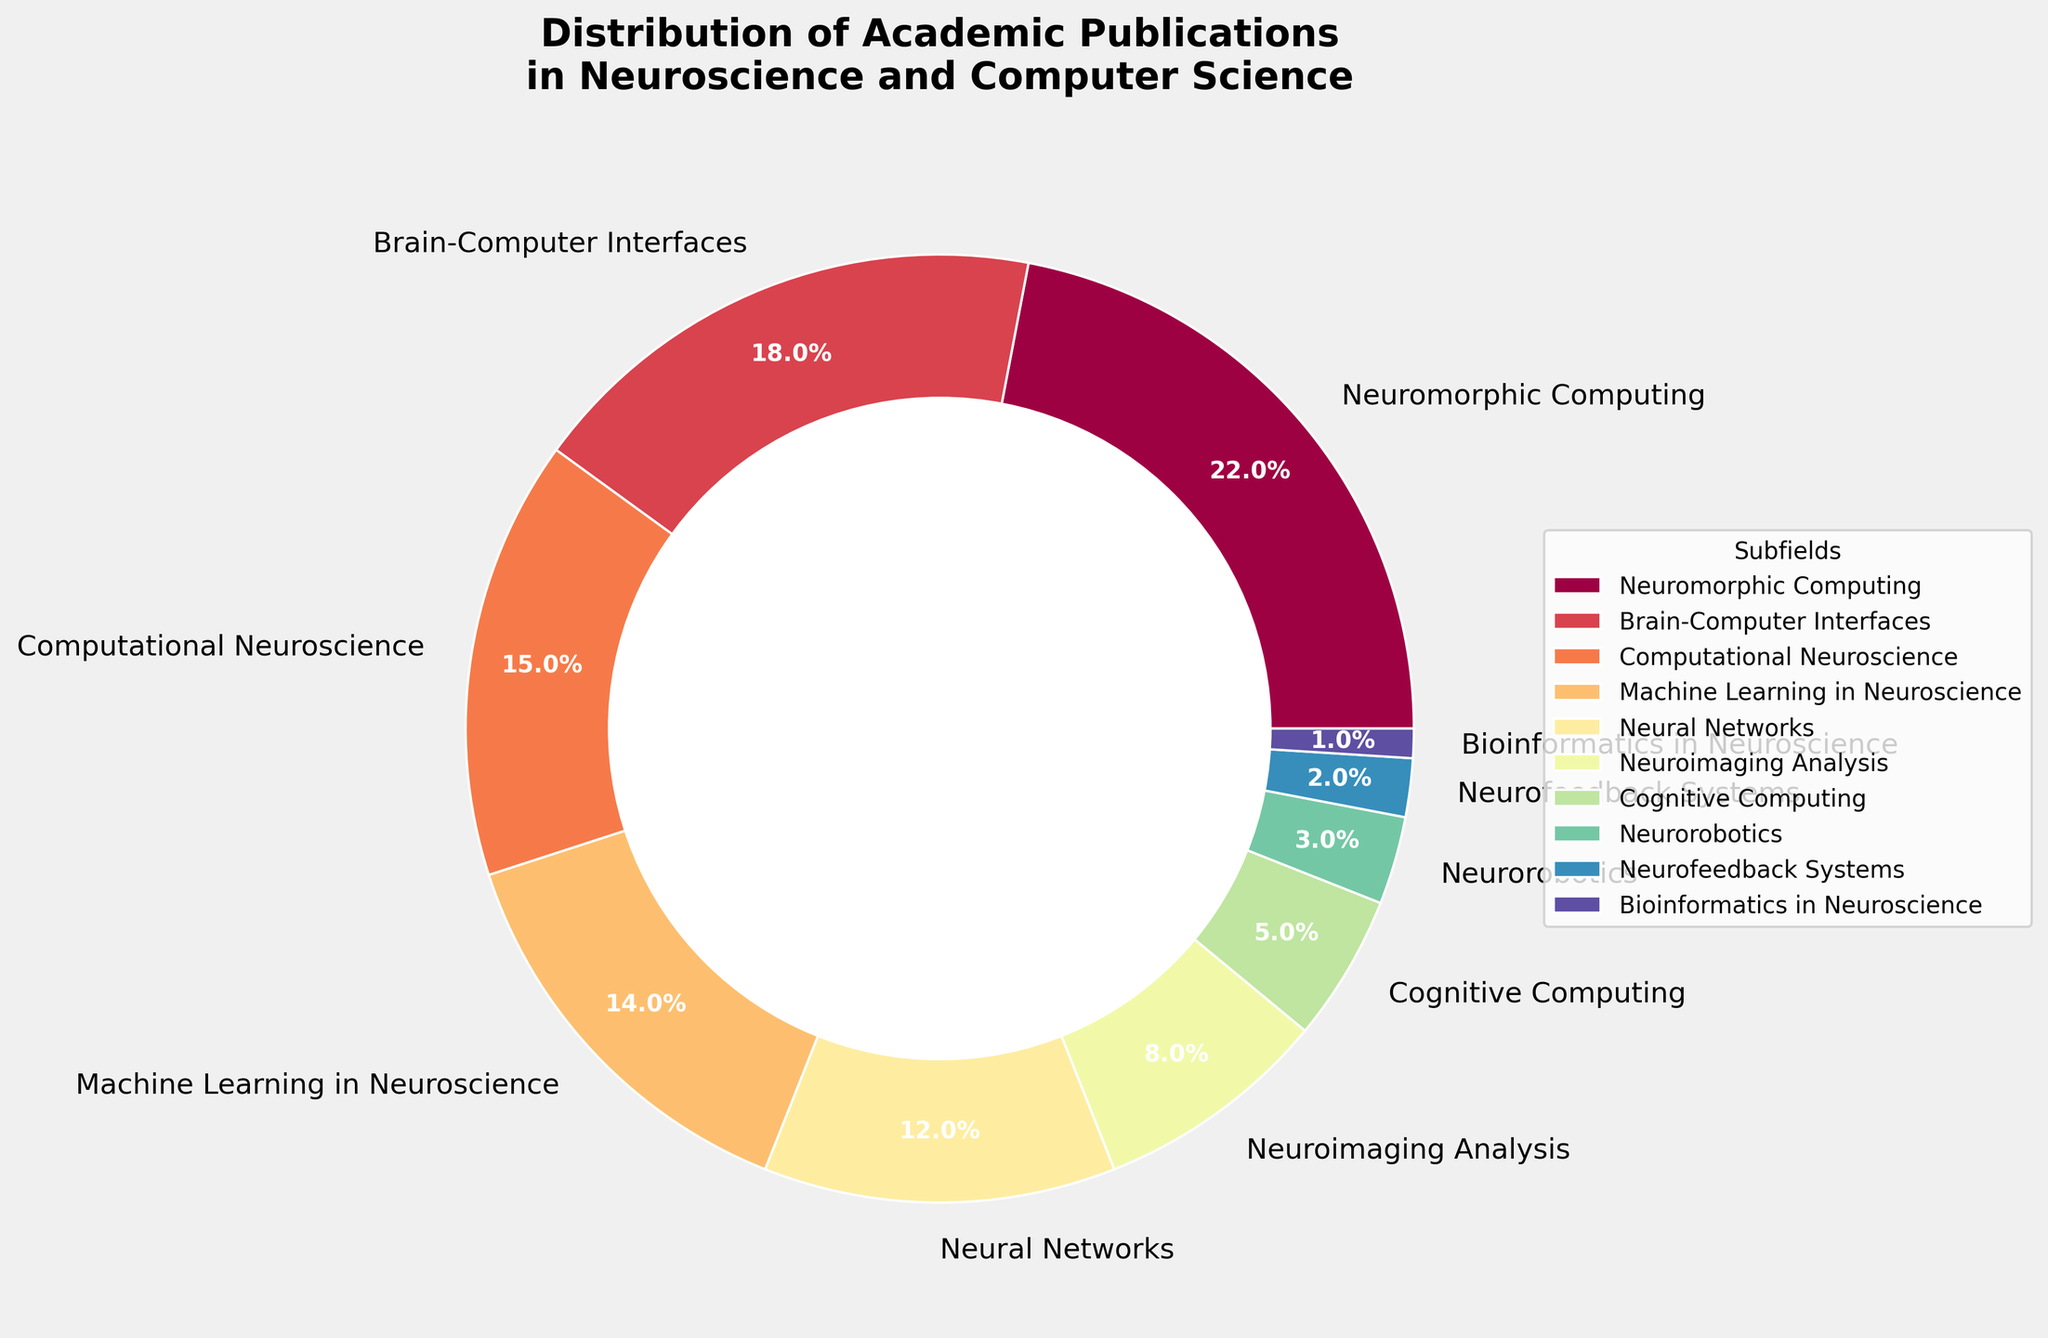Which subfield has the highest percentage of academic publications? The subfield with the largest percentage slice in the pie chart is Neuromorphic Computing at 22%.
Answer: Neuromorphic Computing What is the combined percentage of publications for Brain-Computer Interfaces, Computational Neuroscience, and Machine Learning in Neuroscience? Sum the percentages of Brain-Computer Interfaces (18%), Computational Neuroscience (15%), and Machine Learning in Neuroscience (14%): 18 + 15 + 14 = 47%.
Answer: 47% Which subfield has a lower percentage of publications than Neural Networks but higher than Neuroimaging Analysis? Neural Networks has 12% and Neuroimaging Analysis has 8%. The subfield with a percentage between these values is Machine Learning in Neuroscience at 14%.
Answer: Machine Learning in Neuroscience What is the difference in publication percentage between the subfields with the highest and lowest percentages? Neuromorphic Computing has the highest percentage at 22%, and Bioinformatics in Neuroscience has the lowest at 1%. The difference is 22 - 1 = 21%.
Answer: 21% How many subfields have publication percentages above 10%? Count the subfields with percentages above 10%: Neuromorphic Computing (22%), Brain-Computer Interfaces (18%), Computational Neuroscience (15%), Machine Learning in Neuroscience (14%), and Neural Networks (12%).
Answer: 5 Which subfield has a smaller slice than Neuroimaging Analysis but larger than Neurorobotics in the pie chart? Neuroimaging Analysis is at 8% and Neurorobotics is at 3%. Cognitive Computing, at 5%, is the subfield fitting this condition.
Answer: Cognitive Computing If you combine the percentages of the bottom three subfields, what will be the total? Sum the percentages of Cognitive Computing (5%), Neurorobotics (3%), and Neurofeedback Systems (2%): 5 + 3 + 2 = 10%.
Answer: 10% What percentage of publications combine to form the outer ring covering the widest visual area? The subfield with the widest slice in the pie chart is Neuromorphic Computing at 22%.
Answer: 22% Which subfield shares the lightest color in the plot? Observing the color gradient from light to dark, Bioinformatics in Neuroscience has the lightest color corresponding to its lowest percentage.
Answer: Bioinformatics in Neuroscience 